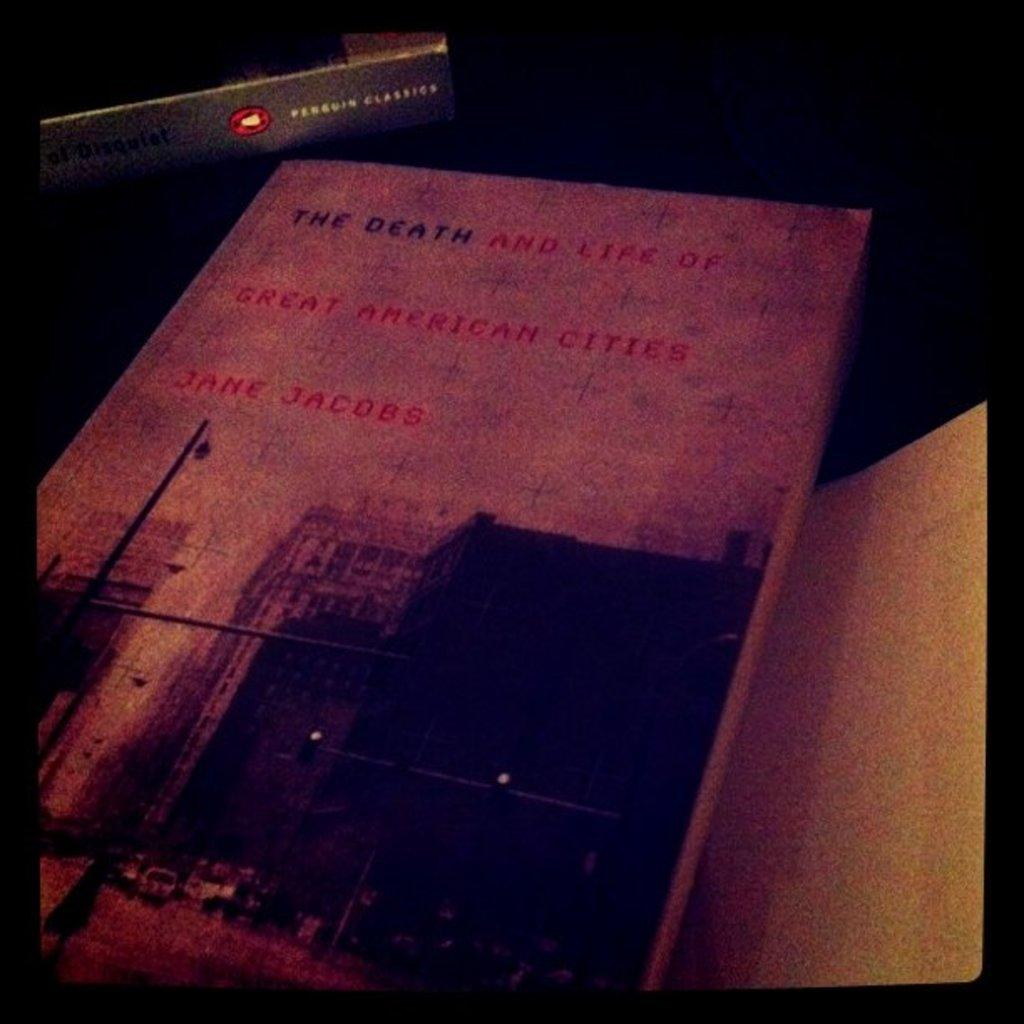<image>
Create a compact narrative representing the image presented. An old book by Jane Jacobs called The Death and Life of Great American Cities. 